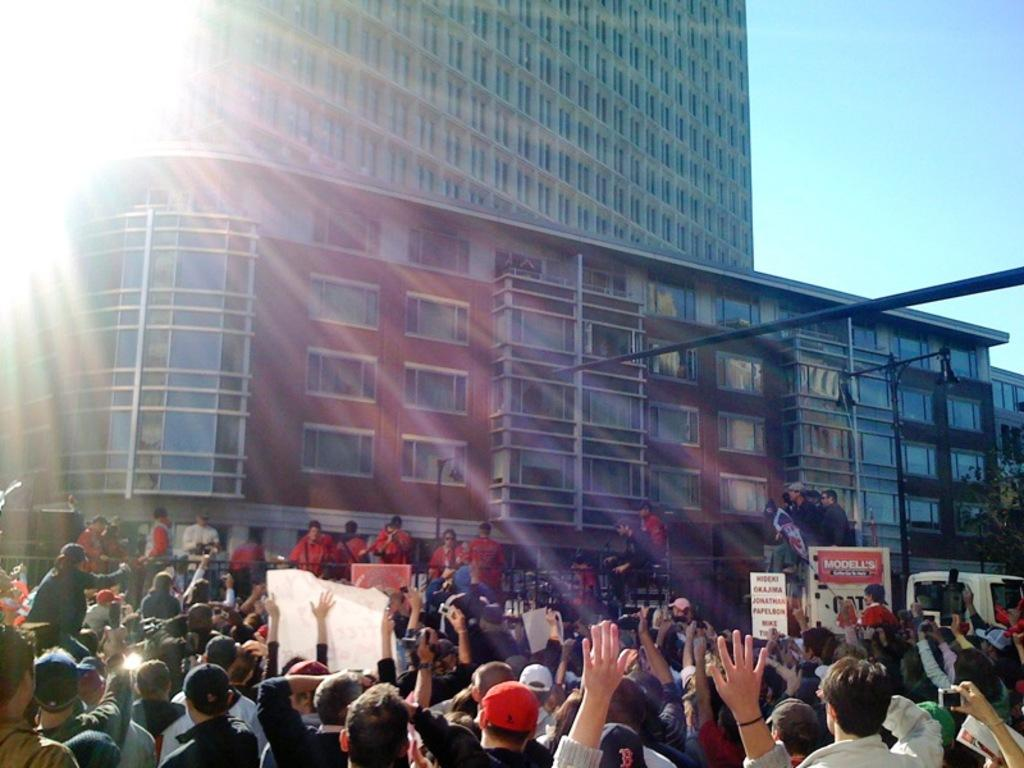What type of structure is present in the image? There is a building in the image. What features can be observed on the building? The building has windows and rods. Are there any people present in the image? Yes, there are people in the image. What else can be seen in the image besides the building and people? There is a vehicle in the image. What is visible in the background of the image? The sky is visible in the background of the image. What type of arch can be seen supporting the building in the image? There is no arch visible in the image; the building's structure is not described in detail. How many quivers are present in the image? There are no quivers present in the image. 